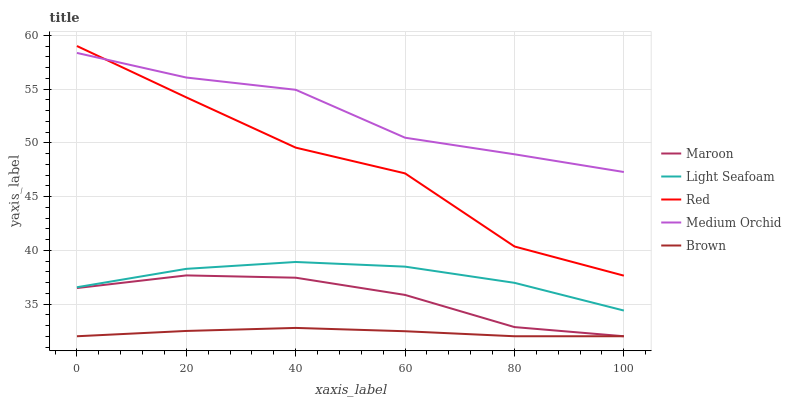Does Brown have the minimum area under the curve?
Answer yes or no. Yes. Does Medium Orchid have the maximum area under the curve?
Answer yes or no. Yes. Does Light Seafoam have the minimum area under the curve?
Answer yes or no. No. Does Light Seafoam have the maximum area under the curve?
Answer yes or no. No. Is Brown the smoothest?
Answer yes or no. Yes. Is Red the roughest?
Answer yes or no. Yes. Is Medium Orchid the smoothest?
Answer yes or no. No. Is Medium Orchid the roughest?
Answer yes or no. No. Does Light Seafoam have the lowest value?
Answer yes or no. No. Does Medium Orchid have the highest value?
Answer yes or no. No. Is Brown less than Medium Orchid?
Answer yes or no. Yes. Is Medium Orchid greater than Brown?
Answer yes or no. Yes. Does Brown intersect Medium Orchid?
Answer yes or no. No. 